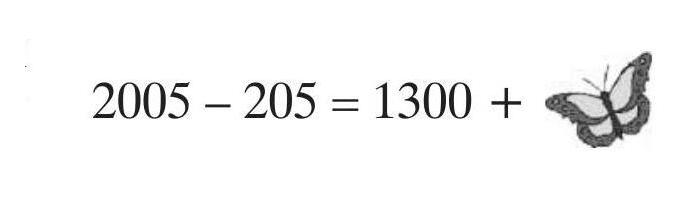A butterfly sat down on a correctly solved exercise. What number is the butterfly covering? The number covered by the butterfly is 500. This is deduced by following the arithmetic operation shown before the butterfly: 2005 minus 205 equals 1300, suggesting that the number sequence continues seamlessly post 1300, leading right up to where the butterfly is perched—on the 500. 